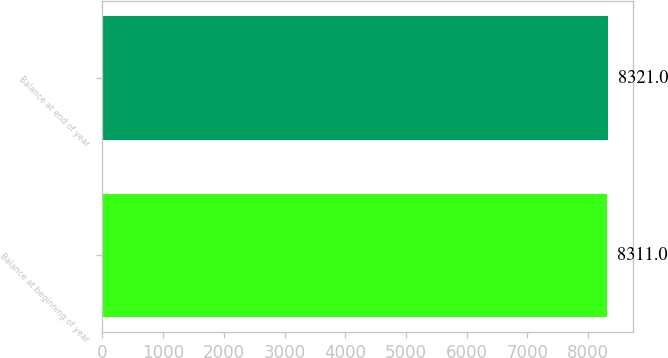<chart> <loc_0><loc_0><loc_500><loc_500><bar_chart><fcel>Balance at beginning of year<fcel>Balance at end of year<nl><fcel>8311<fcel>8321<nl></chart> 